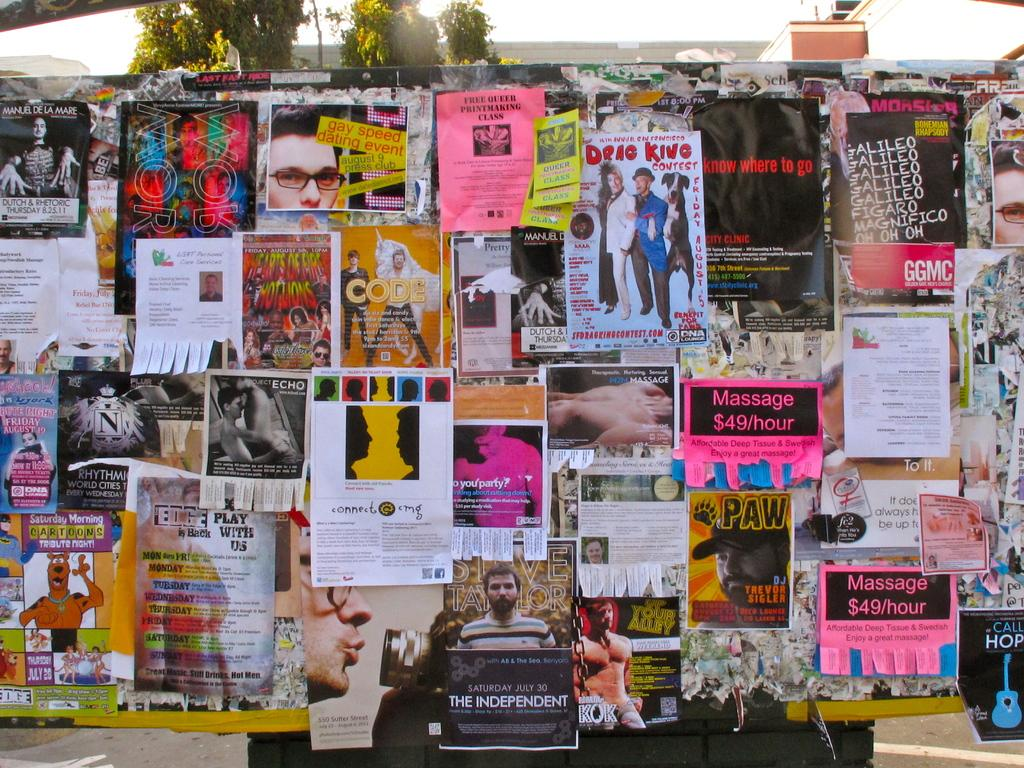What is the main object in the image? There is a board in the image. What is on the board? Posters are pasted on the board. What can be seen in the background of the image? There are trees and the sky visible in the background of the image. What type of structures are visible in the image? There are buildings in the image. Can you tell me what statement the donkey is making in the image? There is no donkey present in the image, so it cannot make any statements. How fast is the snail moving in the image? There is no snail present in the image, so its speed cannot be determined. 